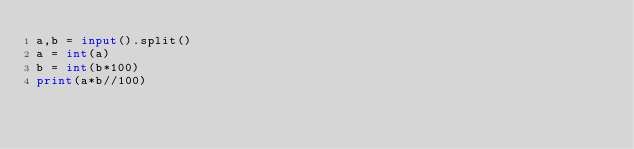Convert code to text. <code><loc_0><loc_0><loc_500><loc_500><_Python_>a,b = input().split()
a = int(a)
b = int(b*100)
print(a*b//100)</code> 